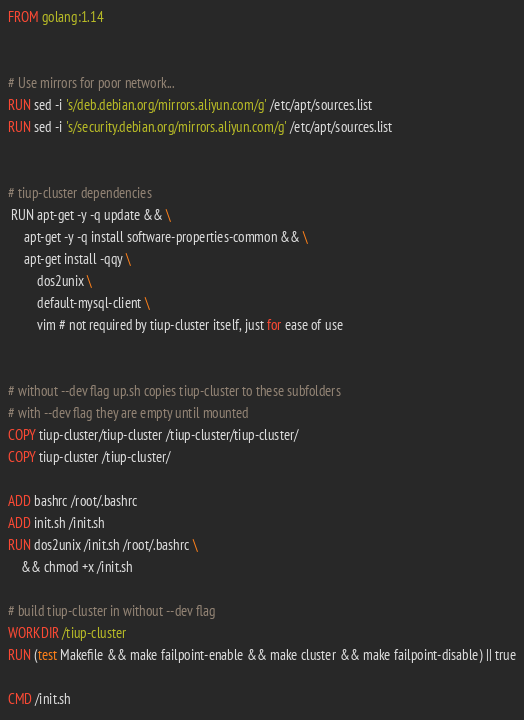<code> <loc_0><loc_0><loc_500><loc_500><_Dockerfile_>FROM golang:1.14


# Use mirrors for poor network...
RUN sed -i 's/deb.debian.org/mirrors.aliyun.com/g' /etc/apt/sources.list
RUN sed -i 's/security.debian.org/mirrors.aliyun.com/g' /etc/apt/sources.list


# tiup-cluster dependencies
 RUN apt-get -y -q update && \
     apt-get -y -q install software-properties-common && \
     apt-get install -qqy \
         dos2unix \
         default-mysql-client \
	     vim # not required by tiup-cluster itself, just for ease of use


# without --dev flag up.sh copies tiup-cluster to these subfolders
# with --dev flag they are empty until mounted
COPY tiup-cluster/tiup-cluster /tiup-cluster/tiup-cluster/
COPY tiup-cluster /tiup-cluster/

ADD bashrc /root/.bashrc
ADD init.sh /init.sh
RUN dos2unix /init.sh /root/.bashrc \
    && chmod +x /init.sh

# build tiup-cluster in without --dev flag
WORKDIR /tiup-cluster
RUN (test Makefile && make failpoint-enable && make cluster && make failpoint-disable) || true

CMD /init.sh
</code> 